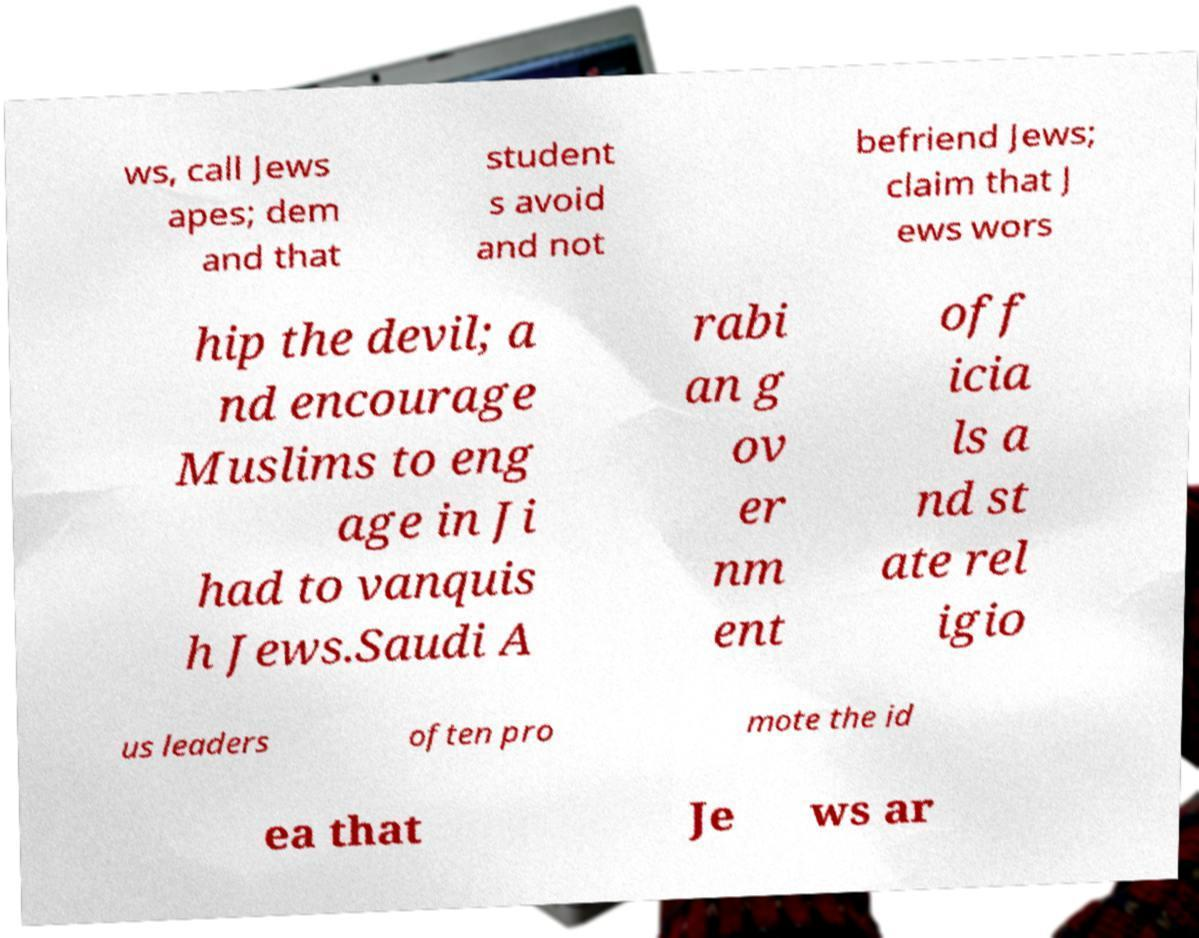Please identify and transcribe the text found in this image. ws, call Jews apes; dem and that student s avoid and not befriend Jews; claim that J ews wors hip the devil; a nd encourage Muslims to eng age in Ji had to vanquis h Jews.Saudi A rabi an g ov er nm ent off icia ls a nd st ate rel igio us leaders often pro mote the id ea that Je ws ar 